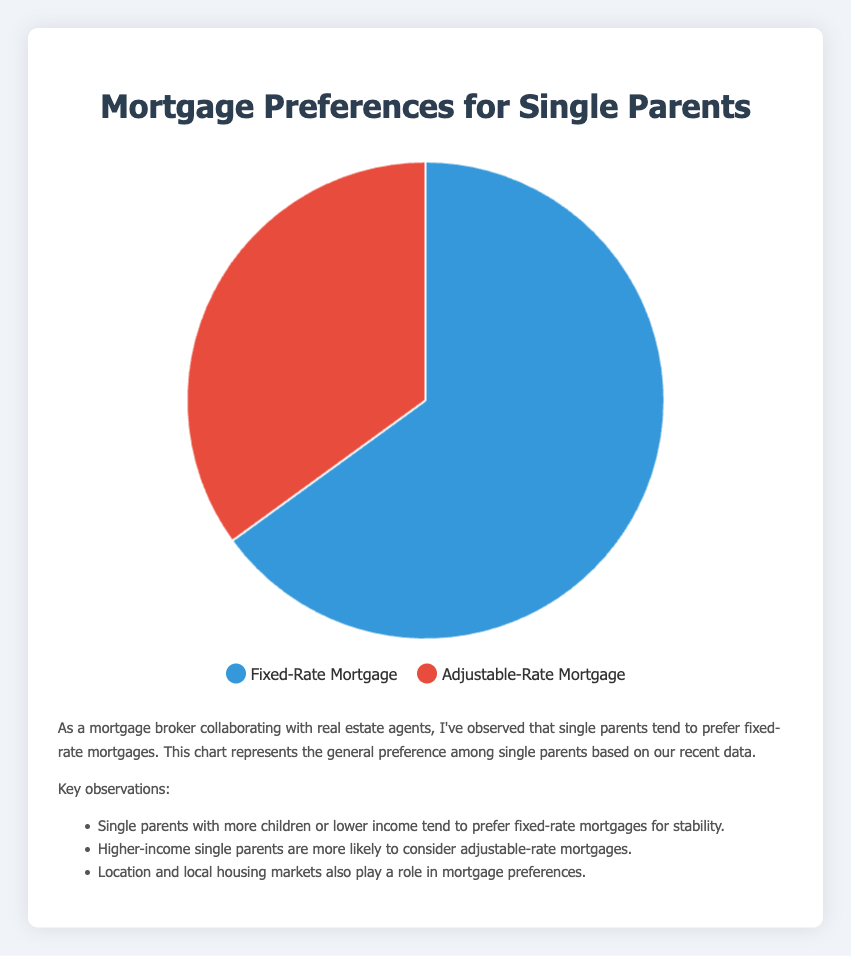What percentage of single parents prefer Fixed-Rate Mortgages? The chart clearly shows that 65% of single parents favor Fixed-Rate Mortgages.
Answer: 65% How much more popular are Fixed-Rate Mortgages compared to Adjustable-Rate Mortgages? To find the difference in popularity, subtract the percentage of Adjustable-Rate Mortgage preferences (35%) from the Fixed-Rate Mortgage preferences (65%). 65% - 35% = 30%.
Answer: 30% Which mortgage type do single parents with 3 children and high income prefer? According to the data provided, Single Parents with 3 Children and high income prefer Fixed-Rate Mortgages with 80% preference.
Answer: Fixed-Rate Mortgages Is the preference for Fixed-Rate Mortgages higher among single parents with low income or high income? Single Parents with low income (2 children) have a 70% preference for Fixed-Rate Mortgages, while single parents with high income (1 child) have a 55% preference. Therefore, it's higher among low-income single parents.
Answer: Low income If a single parent prefers Adjustable-Rate Mortgages, what is the likelihood percentage that they belong to the "Single Parent with 1 Child - High Income" category? For this calculation, we recognize that 45% of single parents in the "Single Parent with 1 Child - High Income" category prefer Adjustable-Rate Mortgages. But since we're only given partial categorical data, the exact likelihood isn't directly calculable from the pie chart alone. We rely on the provided data insights.
Answer: 45% Compare the percentage preferences for Fixed-Rate Mortgages of single parents located in New York City and Seattle. Who has a higher preference? Single parents in New York City (Jane Doe, Middle Income with 1 Child) have a 60% preference for Fixed-Rate Mortgages, while those in Seattle (Emily Johnson, High Income with 3 Children) have an 80% preference. Therefore, Seattle has a higher preference.
Answer: Seattle Which parenting profile shows the smallest difference in preference between Fixed-Rate and Adjustable-Rate Mortgages? Single Parents with 1 Child and High Income have the smallest difference between preferences. The difference is 55% (Fixed) - 45% (Adjustable) = 10%.
Answer: Single Parent with 1 Child - High Income What is the combined percentage for single parents preferring each mortgage type? Summing up: 65% (Fixed-Rate) + 35% (Adjustable-Rate) = 100%. This confirms the total distribution among preferences.
Answer: 100% What overall reason could explain why single parents prefer Fixed-Rate Mortgages according to the insights provided? Based on the insights, fixed-rate mortgages could provide greater financial stability and predictability, which is paramount for single-parent households managing finances on their own.
Answer: Stability and predictability 